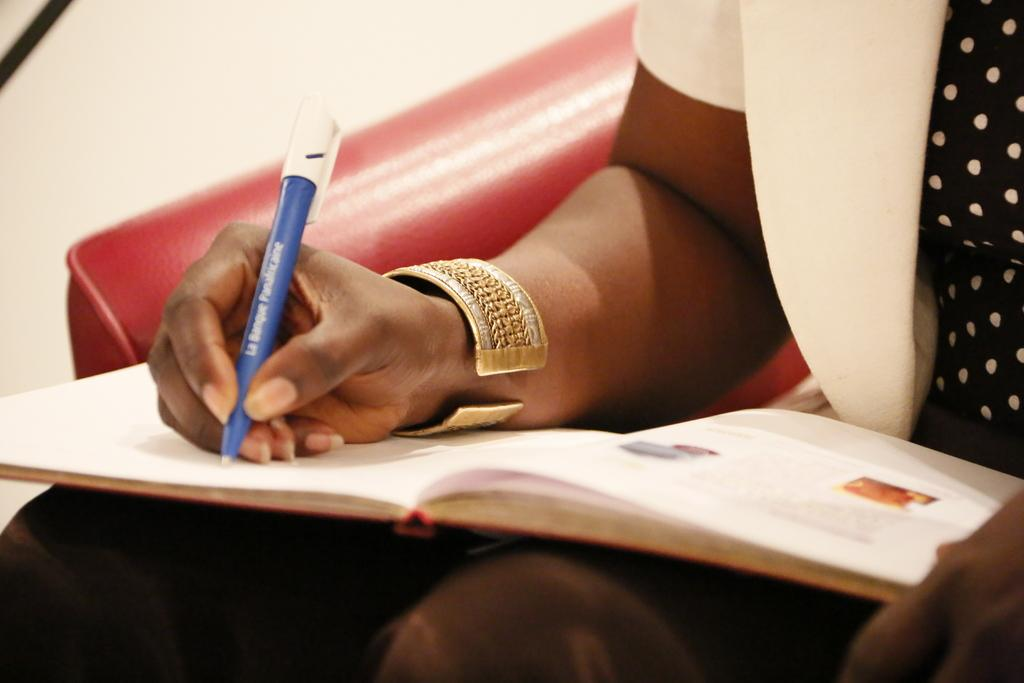Who or what is the main subject in the image? There is a person in the image. What is the person sitting on? The person is sitting on a red chair. What is the person holding? The person is holding a pen. What is the person doing with the pen? The person is writing something. What else can be seen in the image? There is a book in the image. How many trees can be seen in the image? There are no trees visible in the image. What type of sofa is the person sitting on? The person is sitting on a red chair, not a sofa. 